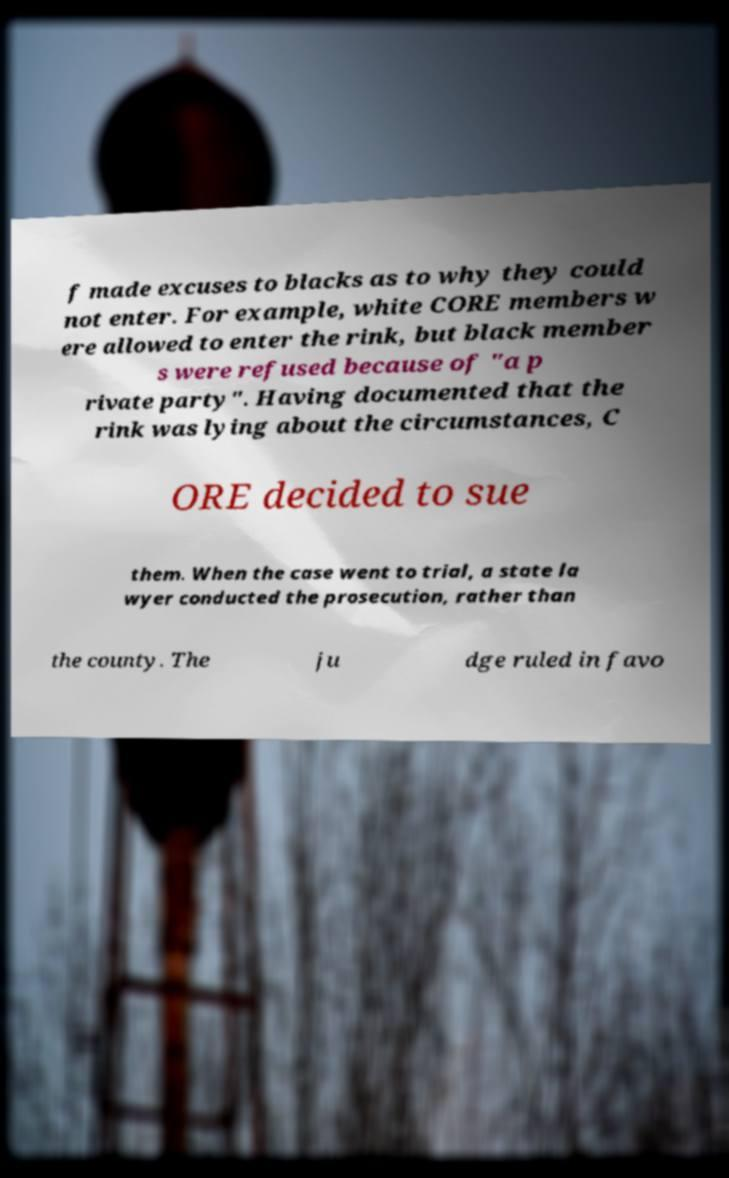There's text embedded in this image that I need extracted. Can you transcribe it verbatim? f made excuses to blacks as to why they could not enter. For example, white CORE members w ere allowed to enter the rink, but black member s were refused because of "a p rivate party". Having documented that the rink was lying about the circumstances, C ORE decided to sue them. When the case went to trial, a state la wyer conducted the prosecution, rather than the county. The ju dge ruled in favo 